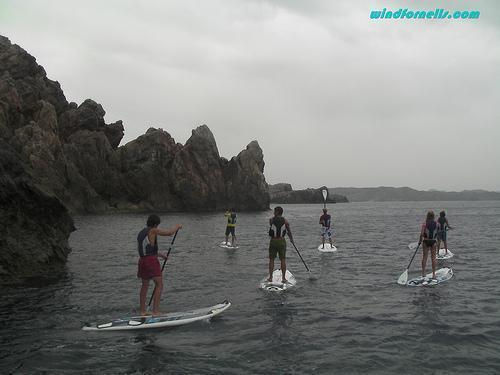How many people are there?
Give a very brief answer. 6. 